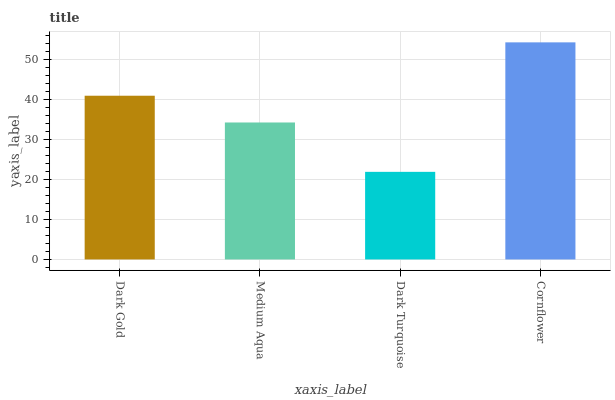Is Dark Turquoise the minimum?
Answer yes or no. Yes. Is Cornflower the maximum?
Answer yes or no. Yes. Is Medium Aqua the minimum?
Answer yes or no. No. Is Medium Aqua the maximum?
Answer yes or no. No. Is Dark Gold greater than Medium Aqua?
Answer yes or no. Yes. Is Medium Aqua less than Dark Gold?
Answer yes or no. Yes. Is Medium Aqua greater than Dark Gold?
Answer yes or no. No. Is Dark Gold less than Medium Aqua?
Answer yes or no. No. Is Dark Gold the high median?
Answer yes or no. Yes. Is Medium Aqua the low median?
Answer yes or no. Yes. Is Cornflower the high median?
Answer yes or no. No. Is Dark Gold the low median?
Answer yes or no. No. 